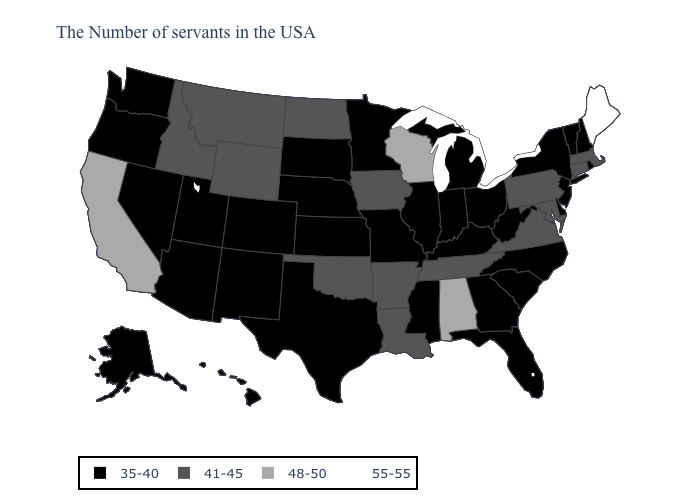Which states hav the highest value in the South?
Be succinct. Alabama. Among the states that border New York , which have the highest value?
Keep it brief. Massachusetts, Connecticut, Pennsylvania. Name the states that have a value in the range 41-45?
Concise answer only. Massachusetts, Connecticut, Maryland, Pennsylvania, Virginia, Tennessee, Louisiana, Arkansas, Iowa, Oklahoma, North Dakota, Wyoming, Montana, Idaho. What is the highest value in the West ?
Answer briefly. 48-50. Does Kentucky have the same value as Rhode Island?
Short answer required. Yes. Name the states that have a value in the range 48-50?
Keep it brief. Alabama, Wisconsin, California. Name the states that have a value in the range 35-40?
Keep it brief. Rhode Island, New Hampshire, Vermont, New York, New Jersey, Delaware, North Carolina, South Carolina, West Virginia, Ohio, Florida, Georgia, Michigan, Kentucky, Indiana, Illinois, Mississippi, Missouri, Minnesota, Kansas, Nebraska, Texas, South Dakota, Colorado, New Mexico, Utah, Arizona, Nevada, Washington, Oregon, Alaska, Hawaii. How many symbols are there in the legend?
Short answer required. 4. What is the lowest value in the USA?
Concise answer only. 35-40. Does Maine have the highest value in the USA?
Write a very short answer. Yes. Among the states that border Florida , does Alabama have the lowest value?
Quick response, please. No. What is the value of Vermont?
Concise answer only. 35-40. Name the states that have a value in the range 55-55?
Keep it brief. Maine. Does the map have missing data?
Quick response, please. No. Does the first symbol in the legend represent the smallest category?
Short answer required. Yes. 